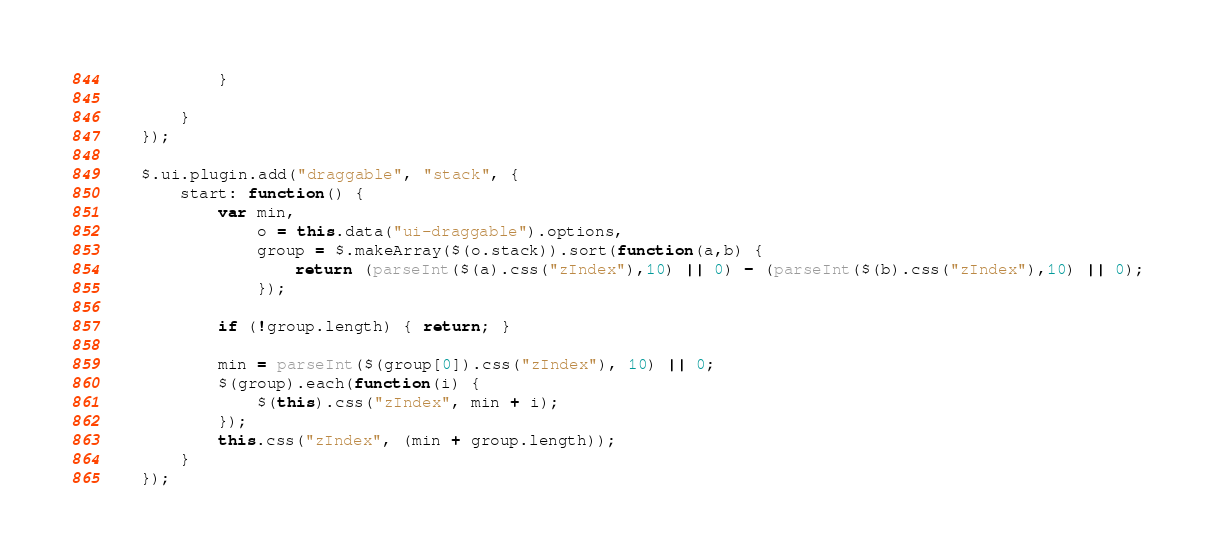Convert code to text. <code><loc_0><loc_0><loc_500><loc_500><_JavaScript_>
            }

        }
    });

    $.ui.plugin.add("draggable", "stack", {
        start: function() {
            var min,
                o = this.data("ui-draggable").options,
                group = $.makeArray($(o.stack)).sort(function(a,b) {
                    return (parseInt($(a).css("zIndex"),10) || 0) - (parseInt($(b).css("zIndex"),10) || 0);
                });

            if (!group.length) { return; }

            min = parseInt($(group[0]).css("zIndex"), 10) || 0;
            $(group).each(function(i) {
                $(this).css("zIndex", min + i);
            });
            this.css("zIndex", (min + group.length));
        }
    });
</code> 